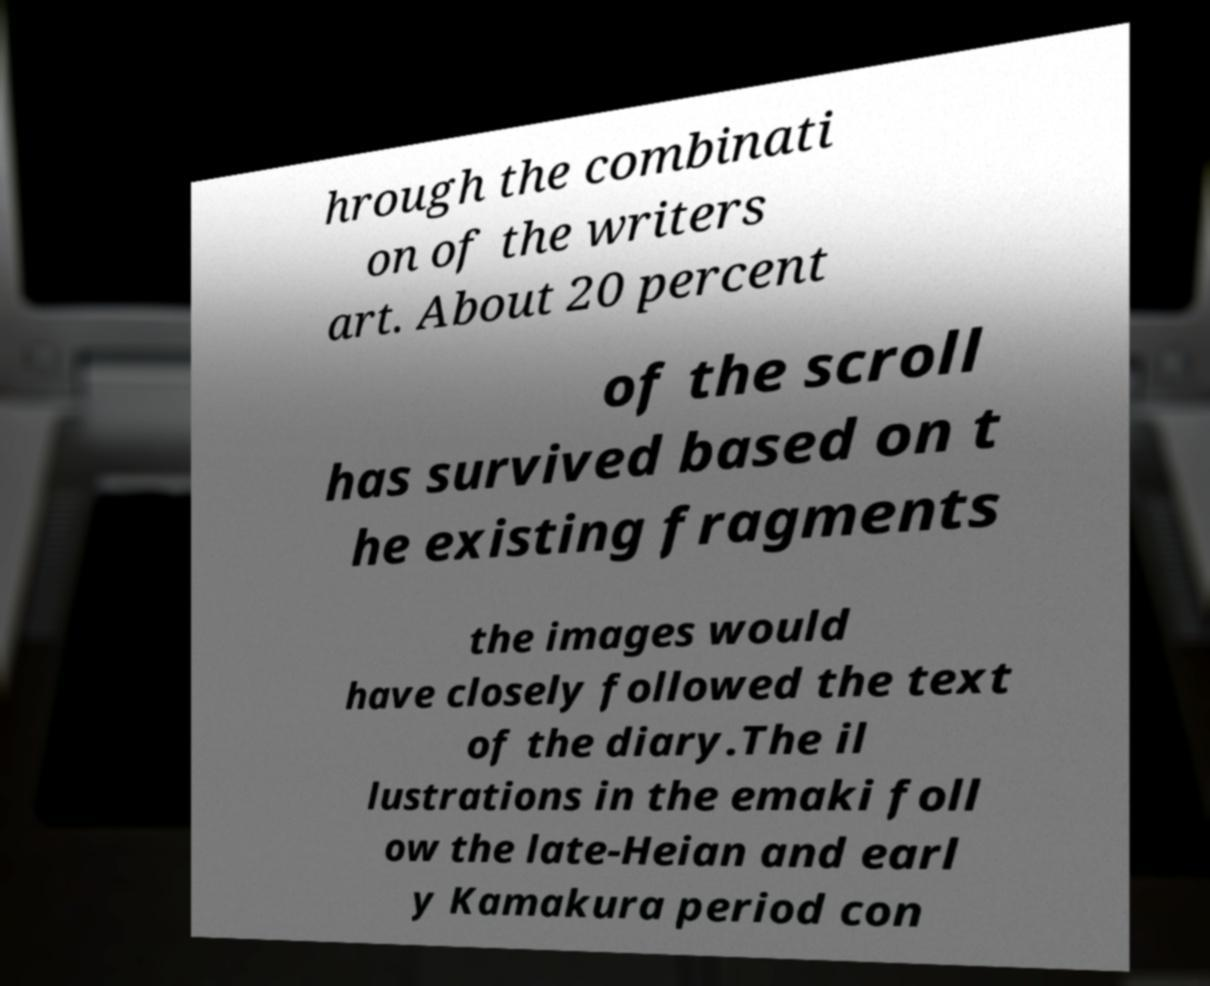There's text embedded in this image that I need extracted. Can you transcribe it verbatim? hrough the combinati on of the writers art. About 20 percent of the scroll has survived based on t he existing fragments the images would have closely followed the text of the diary.The il lustrations in the emaki foll ow the late-Heian and earl y Kamakura period con 